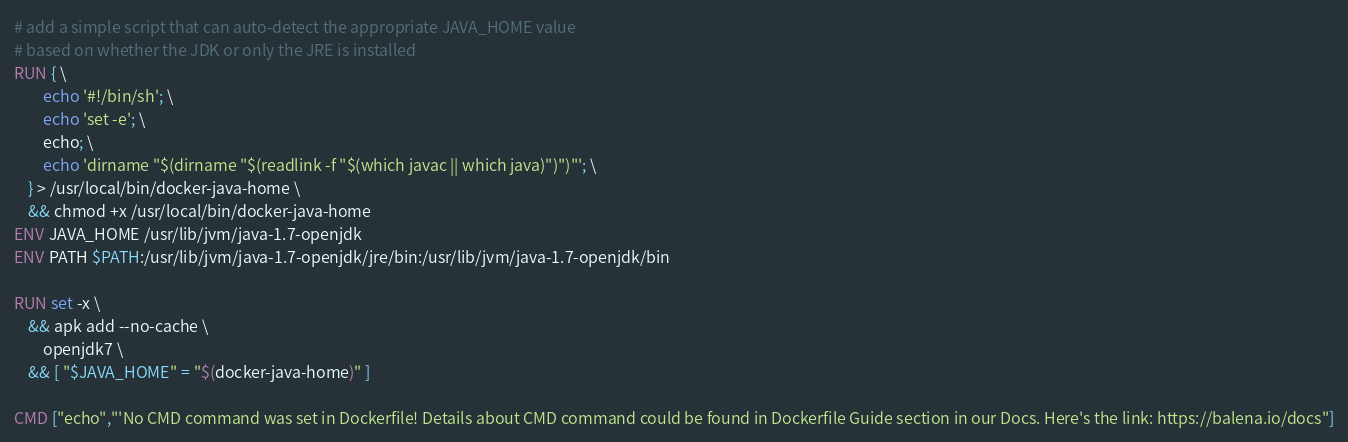<code> <loc_0><loc_0><loc_500><loc_500><_Dockerfile_>
# add a simple script that can auto-detect the appropriate JAVA_HOME value
# based on whether the JDK or only the JRE is installed
RUN { \
		echo '#!/bin/sh'; \
		echo 'set -e'; \
		echo; \
		echo 'dirname "$(dirname "$(readlink -f "$(which javac || which java)")")"'; \
	} > /usr/local/bin/docker-java-home \
	&& chmod +x /usr/local/bin/docker-java-home
ENV JAVA_HOME /usr/lib/jvm/java-1.7-openjdk
ENV PATH $PATH:/usr/lib/jvm/java-1.7-openjdk/jre/bin:/usr/lib/jvm/java-1.7-openjdk/bin

RUN set -x \
	&& apk add --no-cache \
		openjdk7 \
	&& [ "$JAVA_HOME" = "$(docker-java-home)" ]

CMD ["echo","'No CMD command was set in Dockerfile! Details about CMD command could be found in Dockerfile Guide section in our Docs. Here's the link: https://balena.io/docs"]</code> 